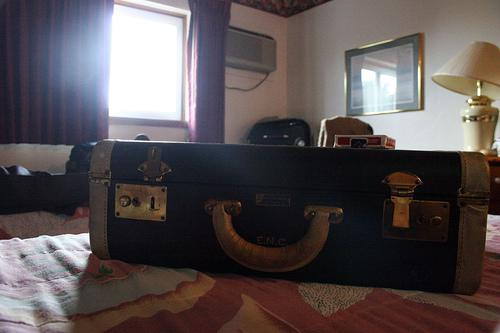Question: where was this photo taken?
Choices:
A. A hotel room.
B. A motel room.
C. House.
D. Office building.
Answer with the letter. Answer: A Question: why can the viewer see the window?
Choices:
A. The blinds are open.
B. The curtains are open.
C. The shutters are open.
D. The windows are broken.
Answer with the letter. Answer: B Question: what color are the briefcase's lock and handle?
Choices:
A. Silver.
B. Gold.
C. Black.
D. White.
Answer with the letter. Answer: B Question: what is next to the curtains on the wall?
Choices:
A. A fan.
B. An air conditioner.
C. A humidifier.
D. A lamp.
Answer with the letter. Answer: B 